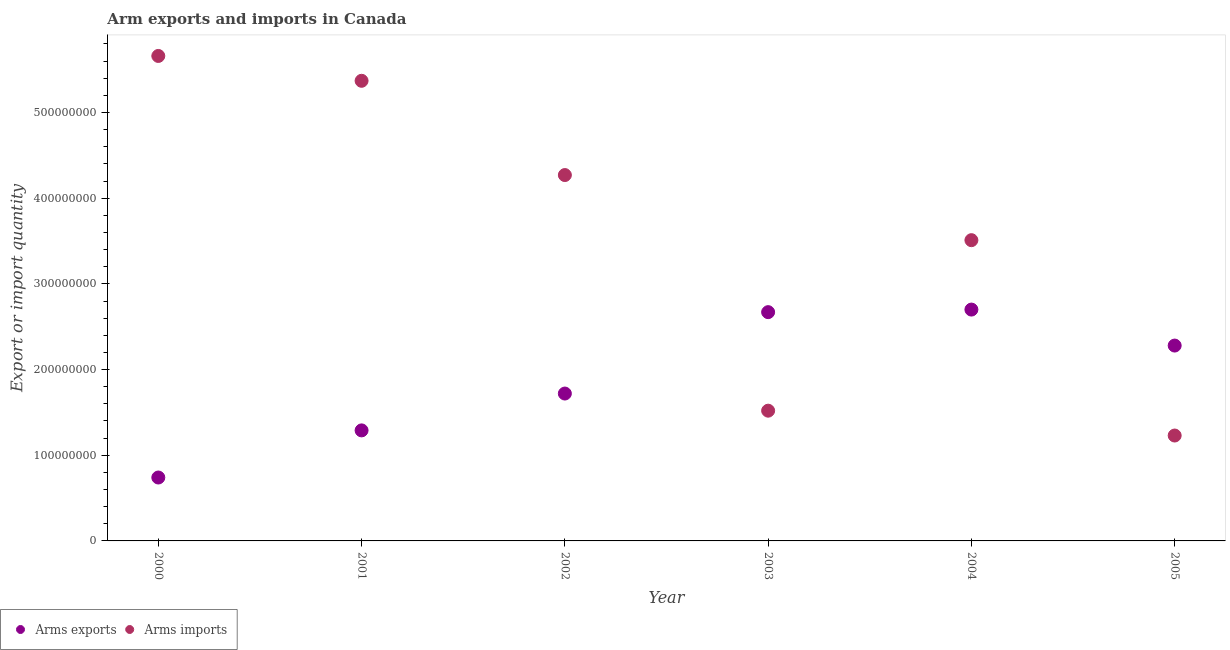What is the arms exports in 2003?
Ensure brevity in your answer.  2.67e+08. Across all years, what is the maximum arms exports?
Give a very brief answer. 2.70e+08. Across all years, what is the minimum arms exports?
Your answer should be very brief. 7.40e+07. In which year was the arms exports maximum?
Provide a succinct answer. 2004. What is the total arms imports in the graph?
Keep it short and to the point. 2.16e+09. What is the difference between the arms exports in 2001 and that in 2002?
Keep it short and to the point. -4.30e+07. What is the difference between the arms imports in 2001 and the arms exports in 2004?
Offer a terse response. 2.67e+08. What is the average arms exports per year?
Give a very brief answer. 1.90e+08. In the year 2003, what is the difference between the arms exports and arms imports?
Your answer should be compact. 1.15e+08. What is the ratio of the arms exports in 2004 to that in 2005?
Provide a short and direct response. 1.18. Is the arms exports in 2001 less than that in 2002?
Your response must be concise. Yes. Is the difference between the arms exports in 2002 and 2003 greater than the difference between the arms imports in 2002 and 2003?
Provide a short and direct response. No. What is the difference between the highest and the lowest arms exports?
Your answer should be very brief. 1.96e+08. Is the arms exports strictly greater than the arms imports over the years?
Ensure brevity in your answer.  No. How many dotlines are there?
Provide a short and direct response. 2. What is the difference between two consecutive major ticks on the Y-axis?
Your answer should be very brief. 1.00e+08. Are the values on the major ticks of Y-axis written in scientific E-notation?
Your answer should be compact. No. Does the graph contain any zero values?
Offer a terse response. No. What is the title of the graph?
Keep it short and to the point. Arm exports and imports in Canada. What is the label or title of the X-axis?
Ensure brevity in your answer.  Year. What is the label or title of the Y-axis?
Make the answer very short. Export or import quantity. What is the Export or import quantity in Arms exports in 2000?
Your response must be concise. 7.40e+07. What is the Export or import quantity of Arms imports in 2000?
Make the answer very short. 5.66e+08. What is the Export or import quantity of Arms exports in 2001?
Give a very brief answer. 1.29e+08. What is the Export or import quantity in Arms imports in 2001?
Provide a short and direct response. 5.37e+08. What is the Export or import quantity of Arms exports in 2002?
Make the answer very short. 1.72e+08. What is the Export or import quantity of Arms imports in 2002?
Ensure brevity in your answer.  4.27e+08. What is the Export or import quantity in Arms exports in 2003?
Your response must be concise. 2.67e+08. What is the Export or import quantity in Arms imports in 2003?
Make the answer very short. 1.52e+08. What is the Export or import quantity in Arms exports in 2004?
Your response must be concise. 2.70e+08. What is the Export or import quantity of Arms imports in 2004?
Offer a terse response. 3.51e+08. What is the Export or import quantity in Arms exports in 2005?
Give a very brief answer. 2.28e+08. What is the Export or import quantity in Arms imports in 2005?
Offer a very short reply. 1.23e+08. Across all years, what is the maximum Export or import quantity of Arms exports?
Make the answer very short. 2.70e+08. Across all years, what is the maximum Export or import quantity in Arms imports?
Give a very brief answer. 5.66e+08. Across all years, what is the minimum Export or import quantity of Arms exports?
Your answer should be compact. 7.40e+07. Across all years, what is the minimum Export or import quantity in Arms imports?
Provide a short and direct response. 1.23e+08. What is the total Export or import quantity of Arms exports in the graph?
Offer a terse response. 1.14e+09. What is the total Export or import quantity in Arms imports in the graph?
Ensure brevity in your answer.  2.16e+09. What is the difference between the Export or import quantity of Arms exports in 2000 and that in 2001?
Your answer should be compact. -5.50e+07. What is the difference between the Export or import quantity of Arms imports in 2000 and that in 2001?
Make the answer very short. 2.90e+07. What is the difference between the Export or import quantity of Arms exports in 2000 and that in 2002?
Keep it short and to the point. -9.80e+07. What is the difference between the Export or import quantity in Arms imports in 2000 and that in 2002?
Make the answer very short. 1.39e+08. What is the difference between the Export or import quantity of Arms exports in 2000 and that in 2003?
Ensure brevity in your answer.  -1.93e+08. What is the difference between the Export or import quantity of Arms imports in 2000 and that in 2003?
Provide a short and direct response. 4.14e+08. What is the difference between the Export or import quantity of Arms exports in 2000 and that in 2004?
Provide a succinct answer. -1.96e+08. What is the difference between the Export or import quantity in Arms imports in 2000 and that in 2004?
Offer a terse response. 2.15e+08. What is the difference between the Export or import quantity in Arms exports in 2000 and that in 2005?
Give a very brief answer. -1.54e+08. What is the difference between the Export or import quantity of Arms imports in 2000 and that in 2005?
Your response must be concise. 4.43e+08. What is the difference between the Export or import quantity of Arms exports in 2001 and that in 2002?
Your answer should be very brief. -4.30e+07. What is the difference between the Export or import quantity of Arms imports in 2001 and that in 2002?
Offer a very short reply. 1.10e+08. What is the difference between the Export or import quantity in Arms exports in 2001 and that in 2003?
Offer a very short reply. -1.38e+08. What is the difference between the Export or import quantity in Arms imports in 2001 and that in 2003?
Give a very brief answer. 3.85e+08. What is the difference between the Export or import quantity of Arms exports in 2001 and that in 2004?
Make the answer very short. -1.41e+08. What is the difference between the Export or import quantity in Arms imports in 2001 and that in 2004?
Give a very brief answer. 1.86e+08. What is the difference between the Export or import quantity in Arms exports in 2001 and that in 2005?
Offer a very short reply. -9.90e+07. What is the difference between the Export or import quantity of Arms imports in 2001 and that in 2005?
Offer a terse response. 4.14e+08. What is the difference between the Export or import quantity in Arms exports in 2002 and that in 2003?
Offer a terse response. -9.50e+07. What is the difference between the Export or import quantity of Arms imports in 2002 and that in 2003?
Provide a short and direct response. 2.75e+08. What is the difference between the Export or import quantity of Arms exports in 2002 and that in 2004?
Keep it short and to the point. -9.80e+07. What is the difference between the Export or import quantity of Arms imports in 2002 and that in 2004?
Your answer should be very brief. 7.60e+07. What is the difference between the Export or import quantity of Arms exports in 2002 and that in 2005?
Your answer should be very brief. -5.60e+07. What is the difference between the Export or import quantity of Arms imports in 2002 and that in 2005?
Offer a very short reply. 3.04e+08. What is the difference between the Export or import quantity of Arms imports in 2003 and that in 2004?
Provide a succinct answer. -1.99e+08. What is the difference between the Export or import quantity in Arms exports in 2003 and that in 2005?
Provide a succinct answer. 3.90e+07. What is the difference between the Export or import quantity of Arms imports in 2003 and that in 2005?
Keep it short and to the point. 2.90e+07. What is the difference between the Export or import quantity of Arms exports in 2004 and that in 2005?
Provide a short and direct response. 4.20e+07. What is the difference between the Export or import quantity of Arms imports in 2004 and that in 2005?
Your answer should be very brief. 2.28e+08. What is the difference between the Export or import quantity of Arms exports in 2000 and the Export or import quantity of Arms imports in 2001?
Make the answer very short. -4.63e+08. What is the difference between the Export or import quantity in Arms exports in 2000 and the Export or import quantity in Arms imports in 2002?
Your answer should be compact. -3.53e+08. What is the difference between the Export or import quantity in Arms exports in 2000 and the Export or import quantity in Arms imports in 2003?
Provide a succinct answer. -7.80e+07. What is the difference between the Export or import quantity of Arms exports in 2000 and the Export or import quantity of Arms imports in 2004?
Your answer should be very brief. -2.77e+08. What is the difference between the Export or import quantity in Arms exports in 2000 and the Export or import quantity in Arms imports in 2005?
Make the answer very short. -4.90e+07. What is the difference between the Export or import quantity of Arms exports in 2001 and the Export or import quantity of Arms imports in 2002?
Your answer should be compact. -2.98e+08. What is the difference between the Export or import quantity in Arms exports in 2001 and the Export or import quantity in Arms imports in 2003?
Make the answer very short. -2.30e+07. What is the difference between the Export or import quantity of Arms exports in 2001 and the Export or import quantity of Arms imports in 2004?
Offer a terse response. -2.22e+08. What is the difference between the Export or import quantity of Arms exports in 2001 and the Export or import quantity of Arms imports in 2005?
Keep it short and to the point. 6.00e+06. What is the difference between the Export or import quantity in Arms exports in 2002 and the Export or import quantity in Arms imports in 2004?
Your response must be concise. -1.79e+08. What is the difference between the Export or import quantity in Arms exports in 2002 and the Export or import quantity in Arms imports in 2005?
Your answer should be very brief. 4.90e+07. What is the difference between the Export or import quantity in Arms exports in 2003 and the Export or import quantity in Arms imports in 2004?
Make the answer very short. -8.40e+07. What is the difference between the Export or import quantity in Arms exports in 2003 and the Export or import quantity in Arms imports in 2005?
Your answer should be very brief. 1.44e+08. What is the difference between the Export or import quantity of Arms exports in 2004 and the Export or import quantity of Arms imports in 2005?
Offer a very short reply. 1.47e+08. What is the average Export or import quantity in Arms exports per year?
Provide a succinct answer. 1.90e+08. What is the average Export or import quantity of Arms imports per year?
Your answer should be compact. 3.59e+08. In the year 2000, what is the difference between the Export or import quantity of Arms exports and Export or import quantity of Arms imports?
Provide a short and direct response. -4.92e+08. In the year 2001, what is the difference between the Export or import quantity in Arms exports and Export or import quantity in Arms imports?
Provide a short and direct response. -4.08e+08. In the year 2002, what is the difference between the Export or import quantity in Arms exports and Export or import quantity in Arms imports?
Your answer should be very brief. -2.55e+08. In the year 2003, what is the difference between the Export or import quantity in Arms exports and Export or import quantity in Arms imports?
Make the answer very short. 1.15e+08. In the year 2004, what is the difference between the Export or import quantity of Arms exports and Export or import quantity of Arms imports?
Your answer should be compact. -8.10e+07. In the year 2005, what is the difference between the Export or import quantity in Arms exports and Export or import quantity in Arms imports?
Provide a succinct answer. 1.05e+08. What is the ratio of the Export or import quantity in Arms exports in 2000 to that in 2001?
Your answer should be very brief. 0.57. What is the ratio of the Export or import quantity of Arms imports in 2000 to that in 2001?
Make the answer very short. 1.05. What is the ratio of the Export or import quantity in Arms exports in 2000 to that in 2002?
Your response must be concise. 0.43. What is the ratio of the Export or import quantity in Arms imports in 2000 to that in 2002?
Your response must be concise. 1.33. What is the ratio of the Export or import quantity in Arms exports in 2000 to that in 2003?
Your response must be concise. 0.28. What is the ratio of the Export or import quantity in Arms imports in 2000 to that in 2003?
Your response must be concise. 3.72. What is the ratio of the Export or import quantity in Arms exports in 2000 to that in 2004?
Provide a short and direct response. 0.27. What is the ratio of the Export or import quantity of Arms imports in 2000 to that in 2004?
Your answer should be very brief. 1.61. What is the ratio of the Export or import quantity in Arms exports in 2000 to that in 2005?
Offer a very short reply. 0.32. What is the ratio of the Export or import quantity of Arms imports in 2000 to that in 2005?
Make the answer very short. 4.6. What is the ratio of the Export or import quantity in Arms imports in 2001 to that in 2002?
Offer a very short reply. 1.26. What is the ratio of the Export or import quantity of Arms exports in 2001 to that in 2003?
Make the answer very short. 0.48. What is the ratio of the Export or import quantity of Arms imports in 2001 to that in 2003?
Provide a short and direct response. 3.53. What is the ratio of the Export or import quantity of Arms exports in 2001 to that in 2004?
Provide a short and direct response. 0.48. What is the ratio of the Export or import quantity of Arms imports in 2001 to that in 2004?
Your answer should be very brief. 1.53. What is the ratio of the Export or import quantity in Arms exports in 2001 to that in 2005?
Offer a very short reply. 0.57. What is the ratio of the Export or import quantity of Arms imports in 2001 to that in 2005?
Provide a short and direct response. 4.37. What is the ratio of the Export or import quantity of Arms exports in 2002 to that in 2003?
Offer a very short reply. 0.64. What is the ratio of the Export or import quantity of Arms imports in 2002 to that in 2003?
Your answer should be compact. 2.81. What is the ratio of the Export or import quantity of Arms exports in 2002 to that in 2004?
Ensure brevity in your answer.  0.64. What is the ratio of the Export or import quantity in Arms imports in 2002 to that in 2004?
Keep it short and to the point. 1.22. What is the ratio of the Export or import quantity in Arms exports in 2002 to that in 2005?
Ensure brevity in your answer.  0.75. What is the ratio of the Export or import quantity of Arms imports in 2002 to that in 2005?
Provide a short and direct response. 3.47. What is the ratio of the Export or import quantity in Arms exports in 2003 to that in 2004?
Your answer should be compact. 0.99. What is the ratio of the Export or import quantity of Arms imports in 2003 to that in 2004?
Your response must be concise. 0.43. What is the ratio of the Export or import quantity of Arms exports in 2003 to that in 2005?
Keep it short and to the point. 1.17. What is the ratio of the Export or import quantity of Arms imports in 2003 to that in 2005?
Ensure brevity in your answer.  1.24. What is the ratio of the Export or import quantity of Arms exports in 2004 to that in 2005?
Keep it short and to the point. 1.18. What is the ratio of the Export or import quantity of Arms imports in 2004 to that in 2005?
Offer a terse response. 2.85. What is the difference between the highest and the second highest Export or import quantity in Arms exports?
Offer a very short reply. 3.00e+06. What is the difference between the highest and the second highest Export or import quantity of Arms imports?
Make the answer very short. 2.90e+07. What is the difference between the highest and the lowest Export or import quantity in Arms exports?
Provide a succinct answer. 1.96e+08. What is the difference between the highest and the lowest Export or import quantity in Arms imports?
Offer a very short reply. 4.43e+08. 